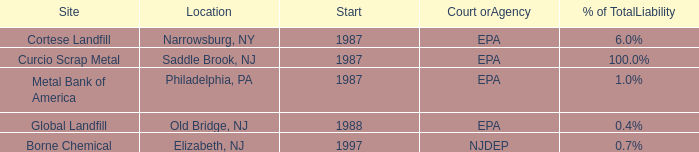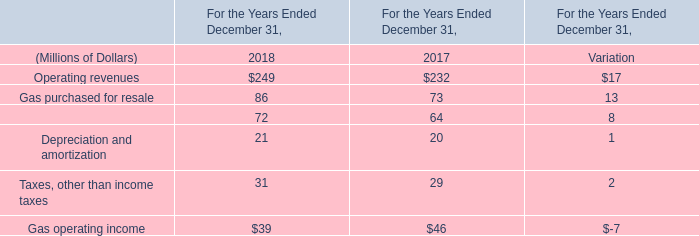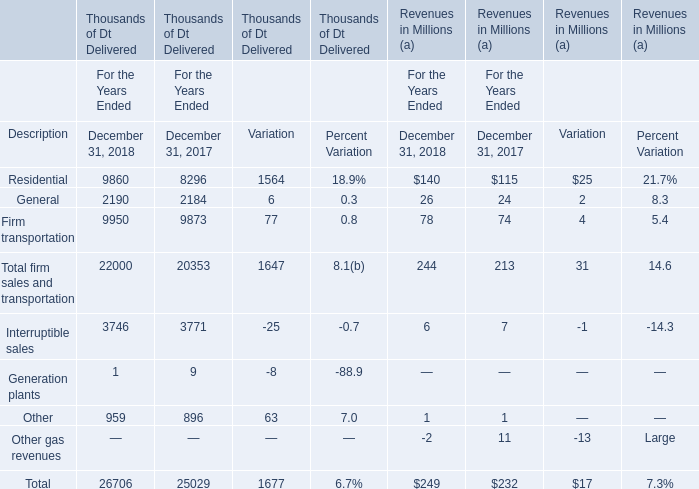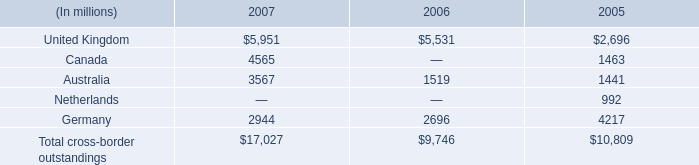What will Residential Revenues reach in 2019 if it continues to grow at its current rate? (in million) 
Computations: (140 + ((140 * (140 - 115)) / 115))
Answer: 170.43478. 